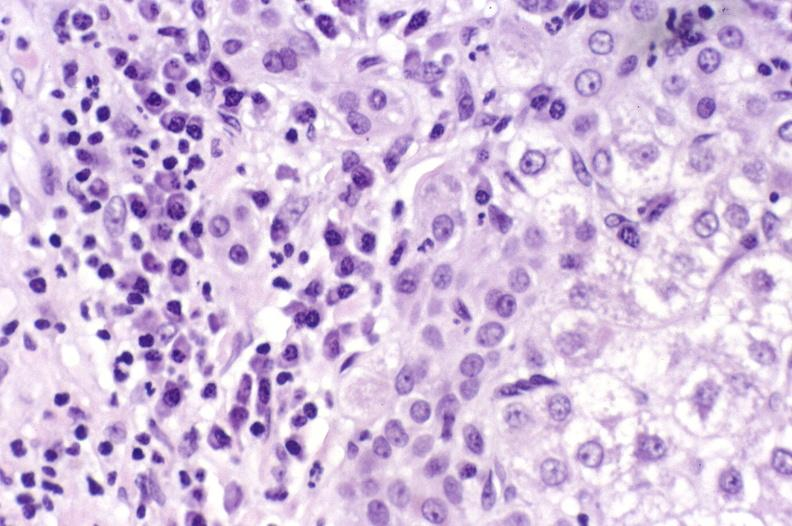does quite good liver show primary biliary cirrhosis?
Answer the question using a single word or phrase. No 